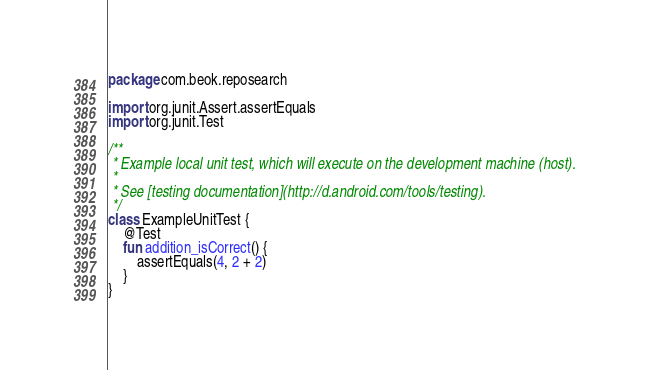Convert code to text. <code><loc_0><loc_0><loc_500><loc_500><_Kotlin_>package com.beok.reposearch

import org.junit.Assert.assertEquals
import org.junit.Test

/**
 * Example local unit test, which will execute on the development machine (host).
 *
 * See [testing documentation](http://d.android.com/tools/testing).
 */
class ExampleUnitTest {
    @Test
    fun addition_isCorrect() {
        assertEquals(4, 2 + 2)
    }
}
</code> 